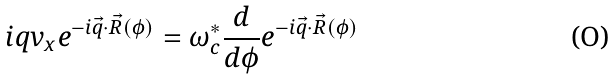<formula> <loc_0><loc_0><loc_500><loc_500>i q v _ { x } e ^ { - i \vec { q } \cdot \vec { R } ( \phi ) } = \omega _ { c } ^ { * } \frac { d } { d \phi } e ^ { - i \vec { q } \cdot \vec { R } ( \phi ) }</formula> 